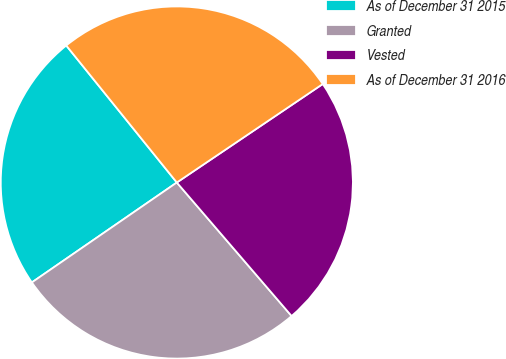Convert chart. <chart><loc_0><loc_0><loc_500><loc_500><pie_chart><fcel>As of December 31 2015<fcel>Granted<fcel>Vested<fcel>As of December 31 2016<nl><fcel>23.8%<fcel>26.7%<fcel>23.15%<fcel>26.36%<nl></chart> 